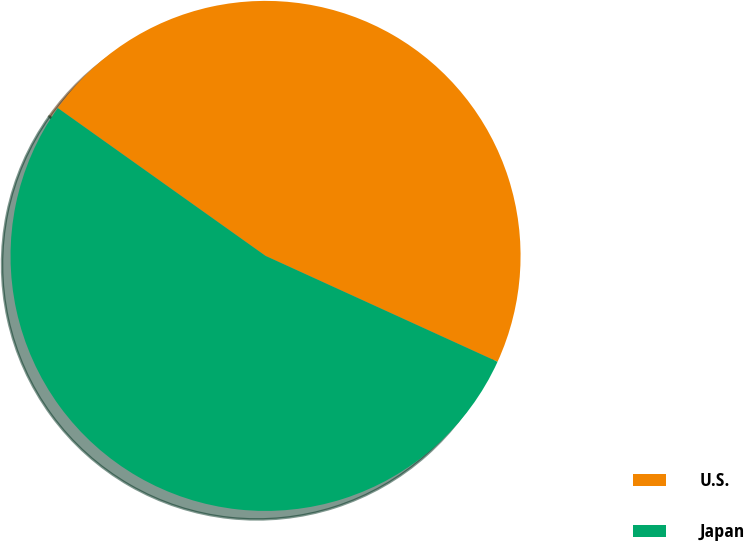<chart> <loc_0><loc_0><loc_500><loc_500><pie_chart><fcel>U.S.<fcel>Japan<nl><fcel>46.97%<fcel>53.03%<nl></chart> 